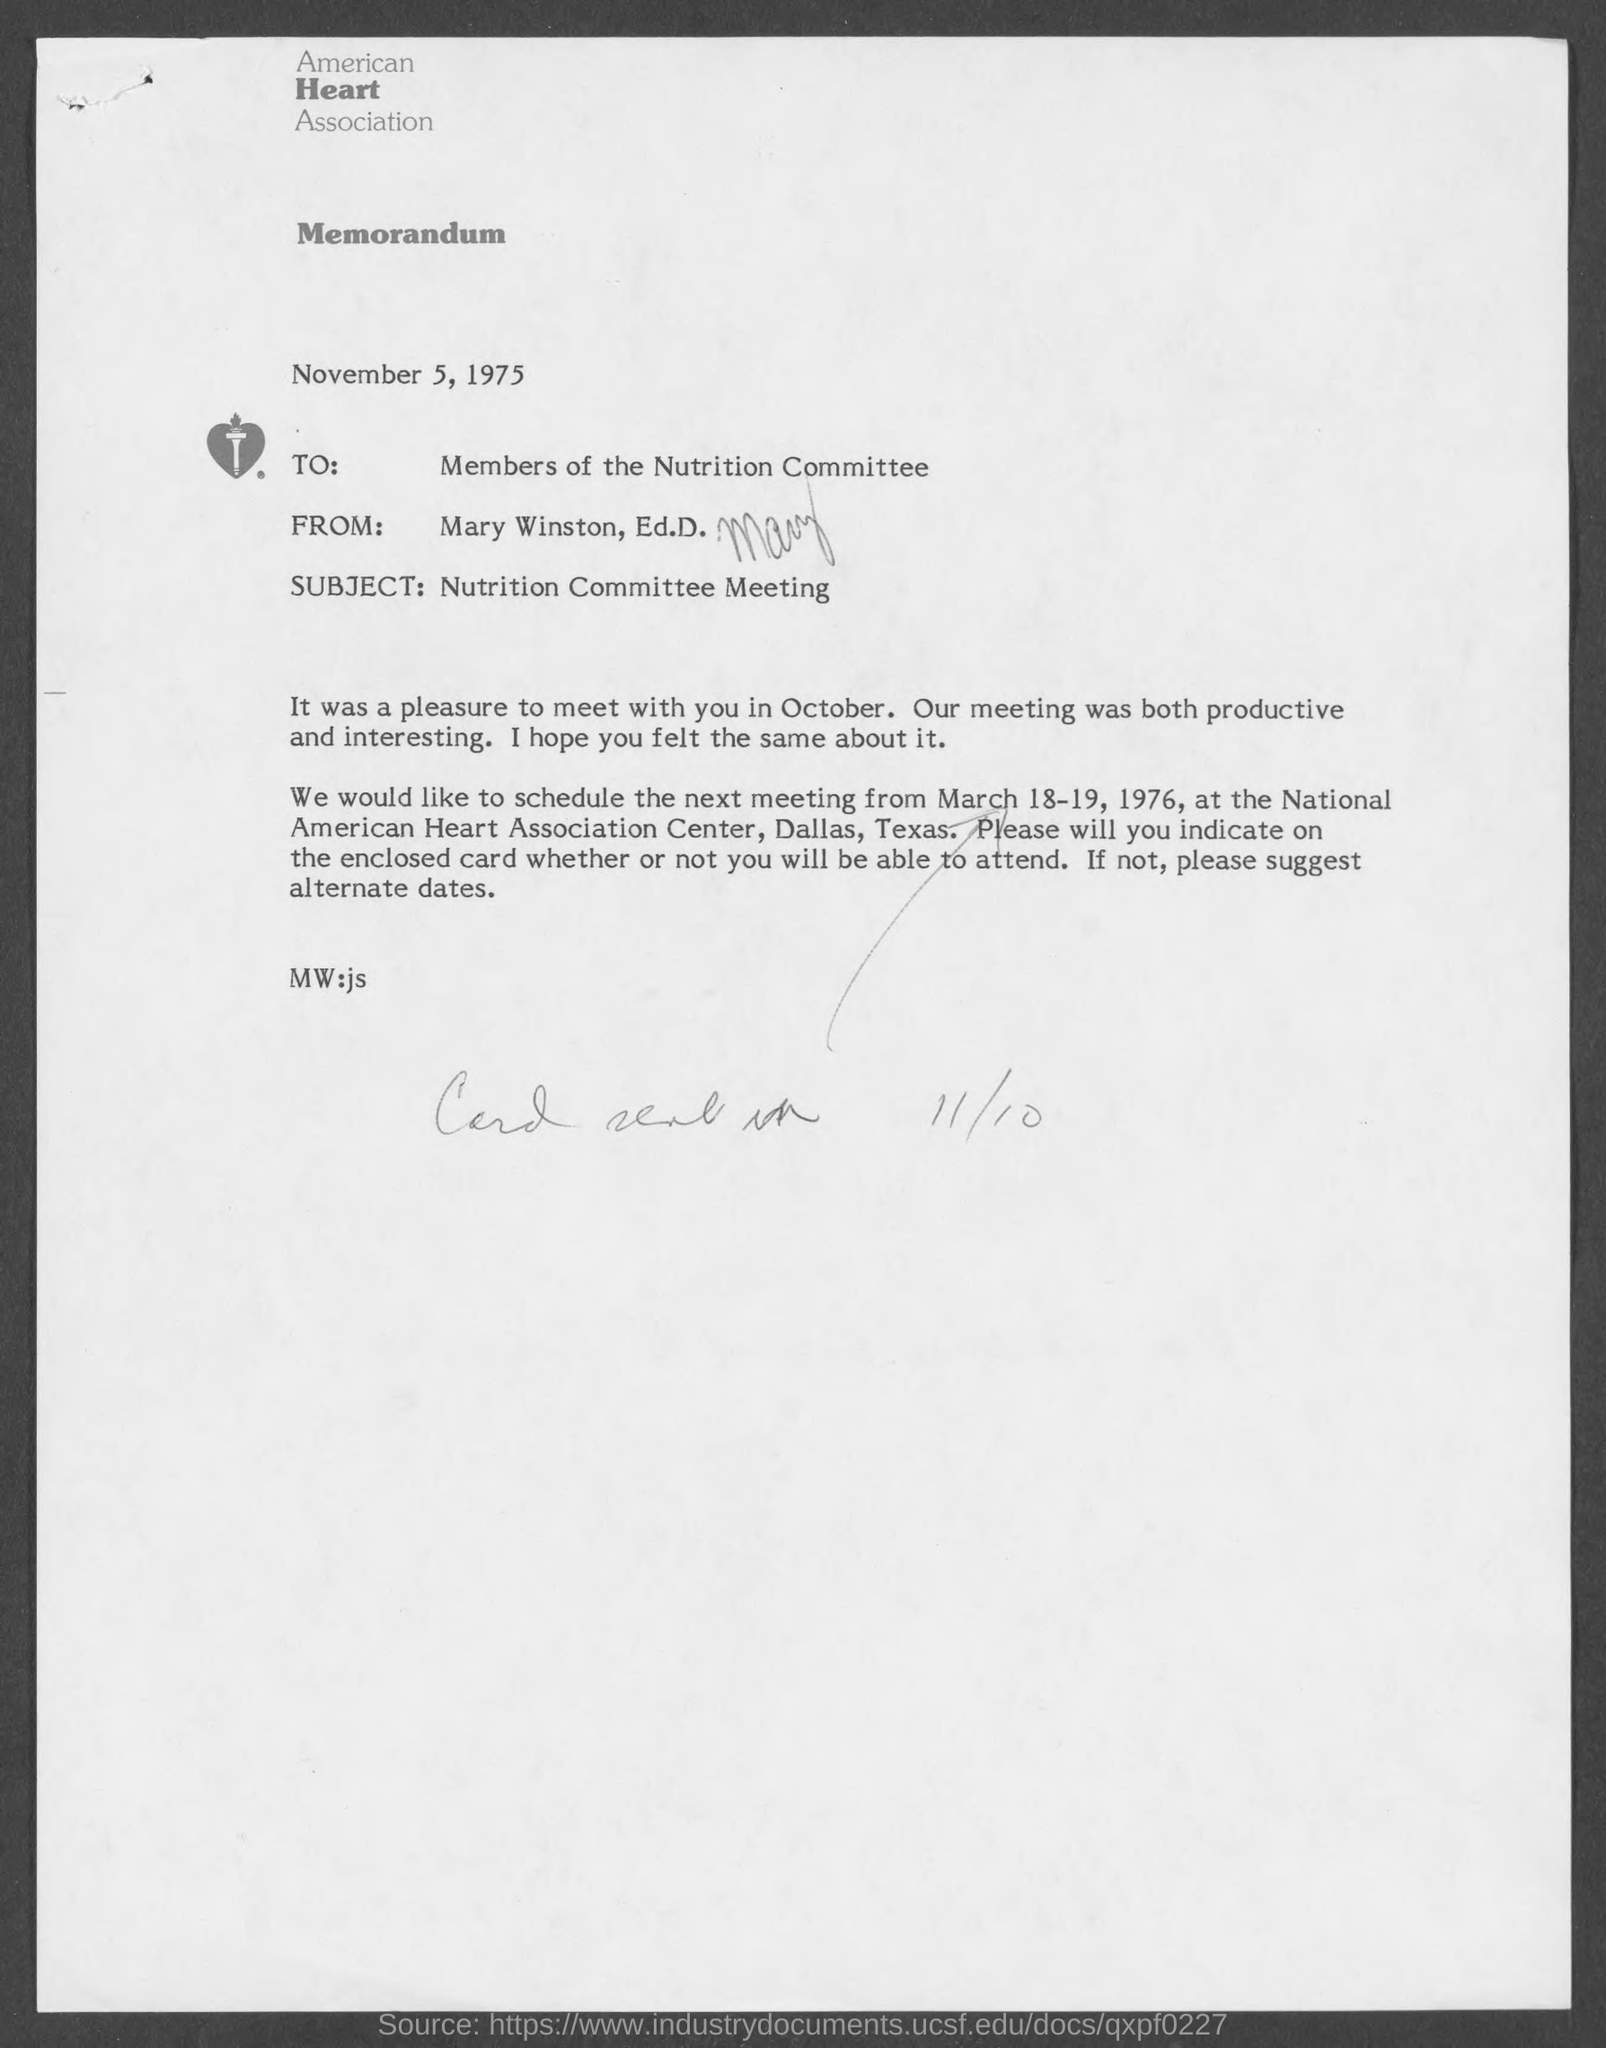Draw attention to some important aspects in this diagram. The subject of the memorandum is the nutrition committee meeting. The memorandum is addressed to the members of the Nutrition Committee. The from address in a memorandum is Mary Winston, Ed.D. The American Heart Association is the name of the organization. 